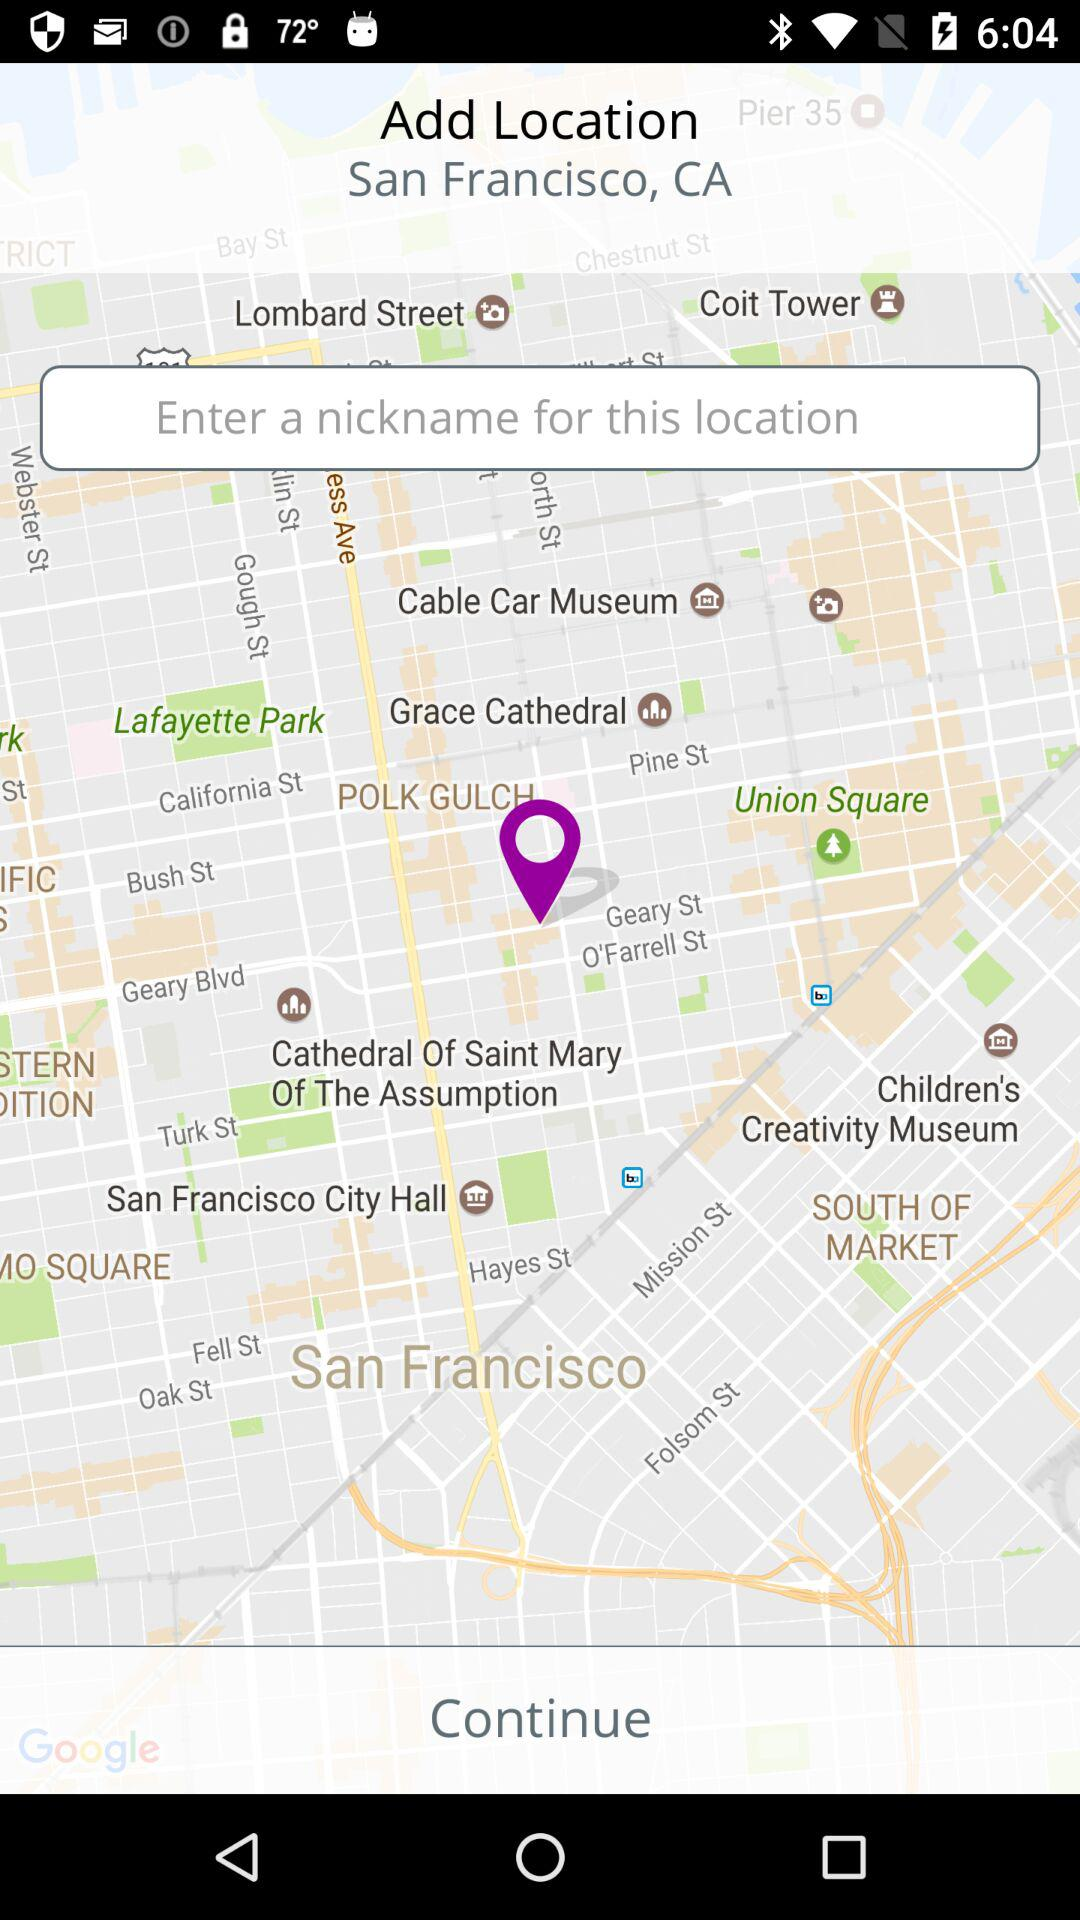What is the location? The location is San Francisco, CA. 